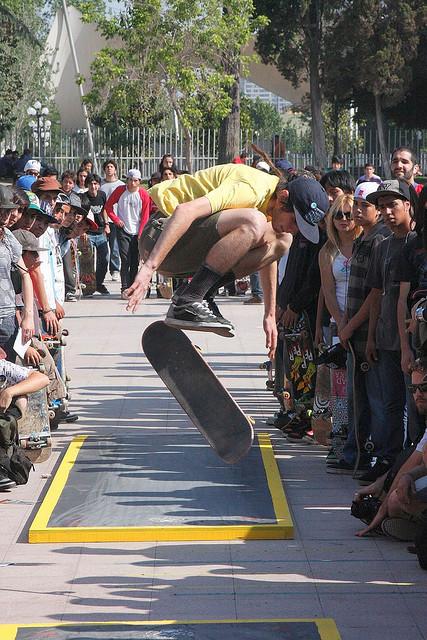Is the skateboard on the ground?
Be succinct. No. Is this a competition?
Write a very short answer. Yes. Is there a lot of people?
Give a very brief answer. Yes. 